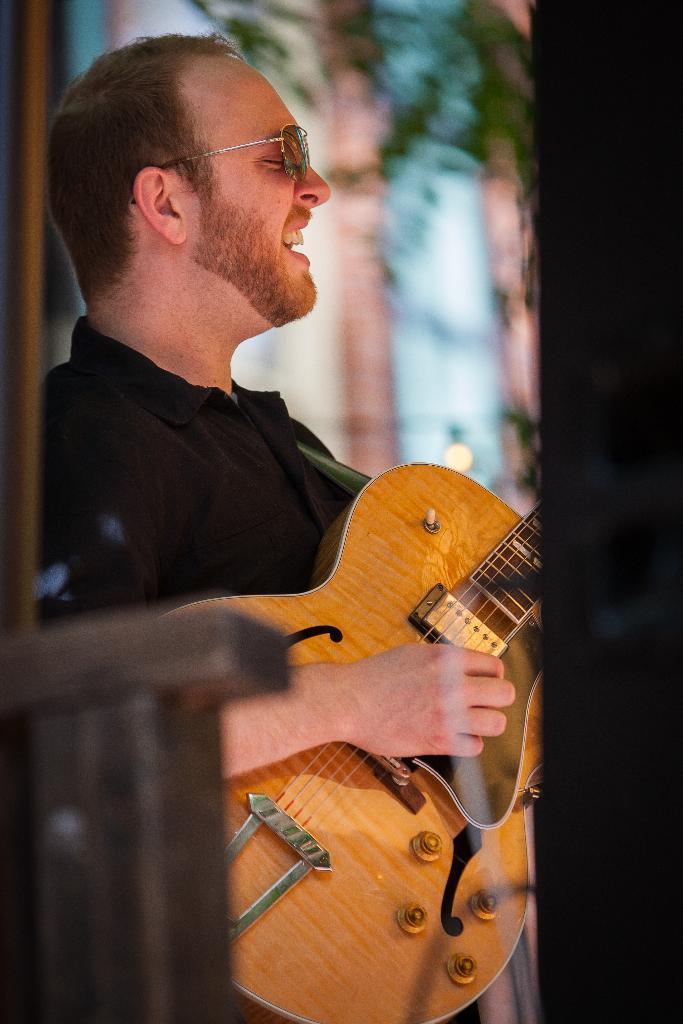Please provide a concise description of this image. The person wearing black shirt is playing guitar and singing. 